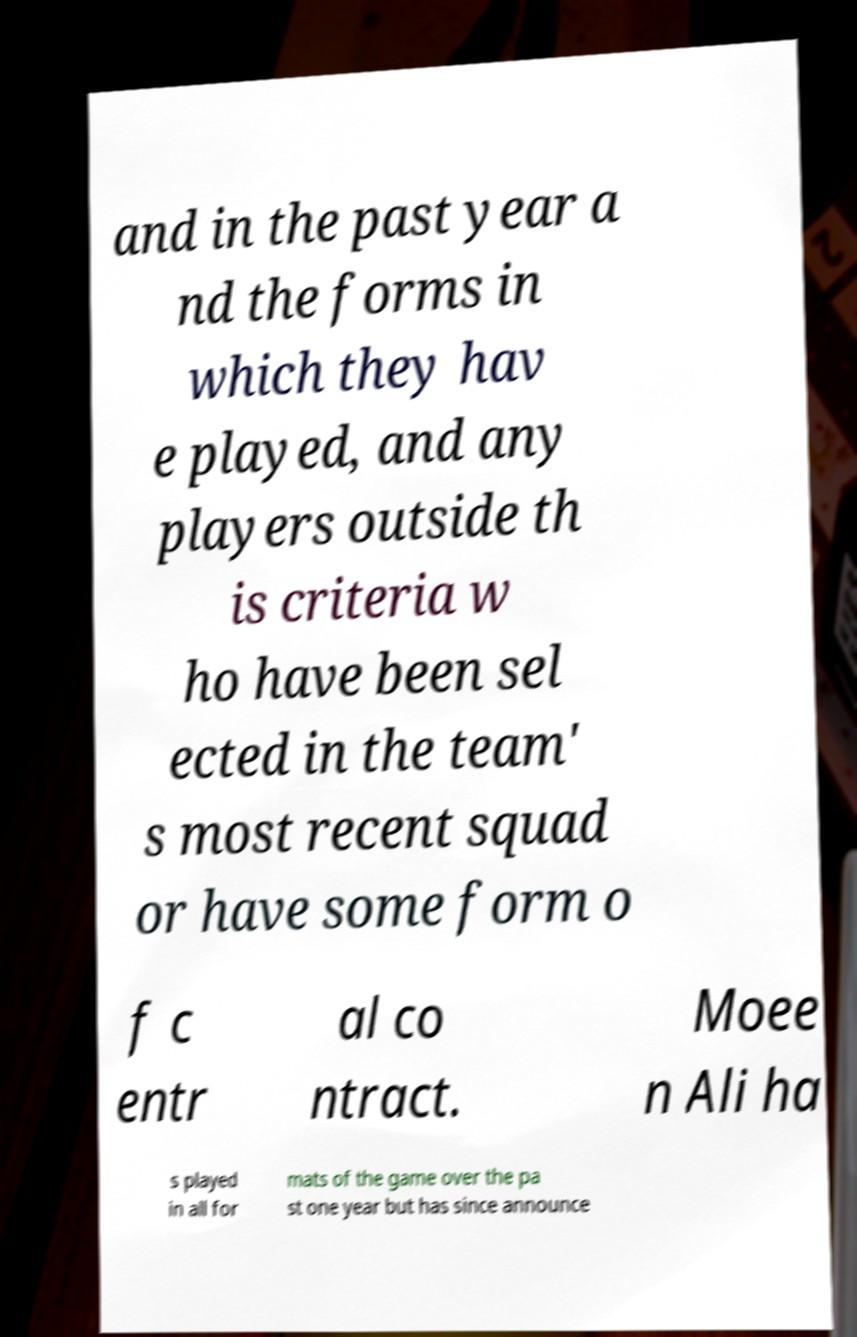Can you read and provide the text displayed in the image?This photo seems to have some interesting text. Can you extract and type it out for me? and in the past year a nd the forms in which they hav e played, and any players outside th is criteria w ho have been sel ected in the team' s most recent squad or have some form o f c entr al co ntract. Moee n Ali ha s played in all for mats of the game over the pa st one year but has since announce 